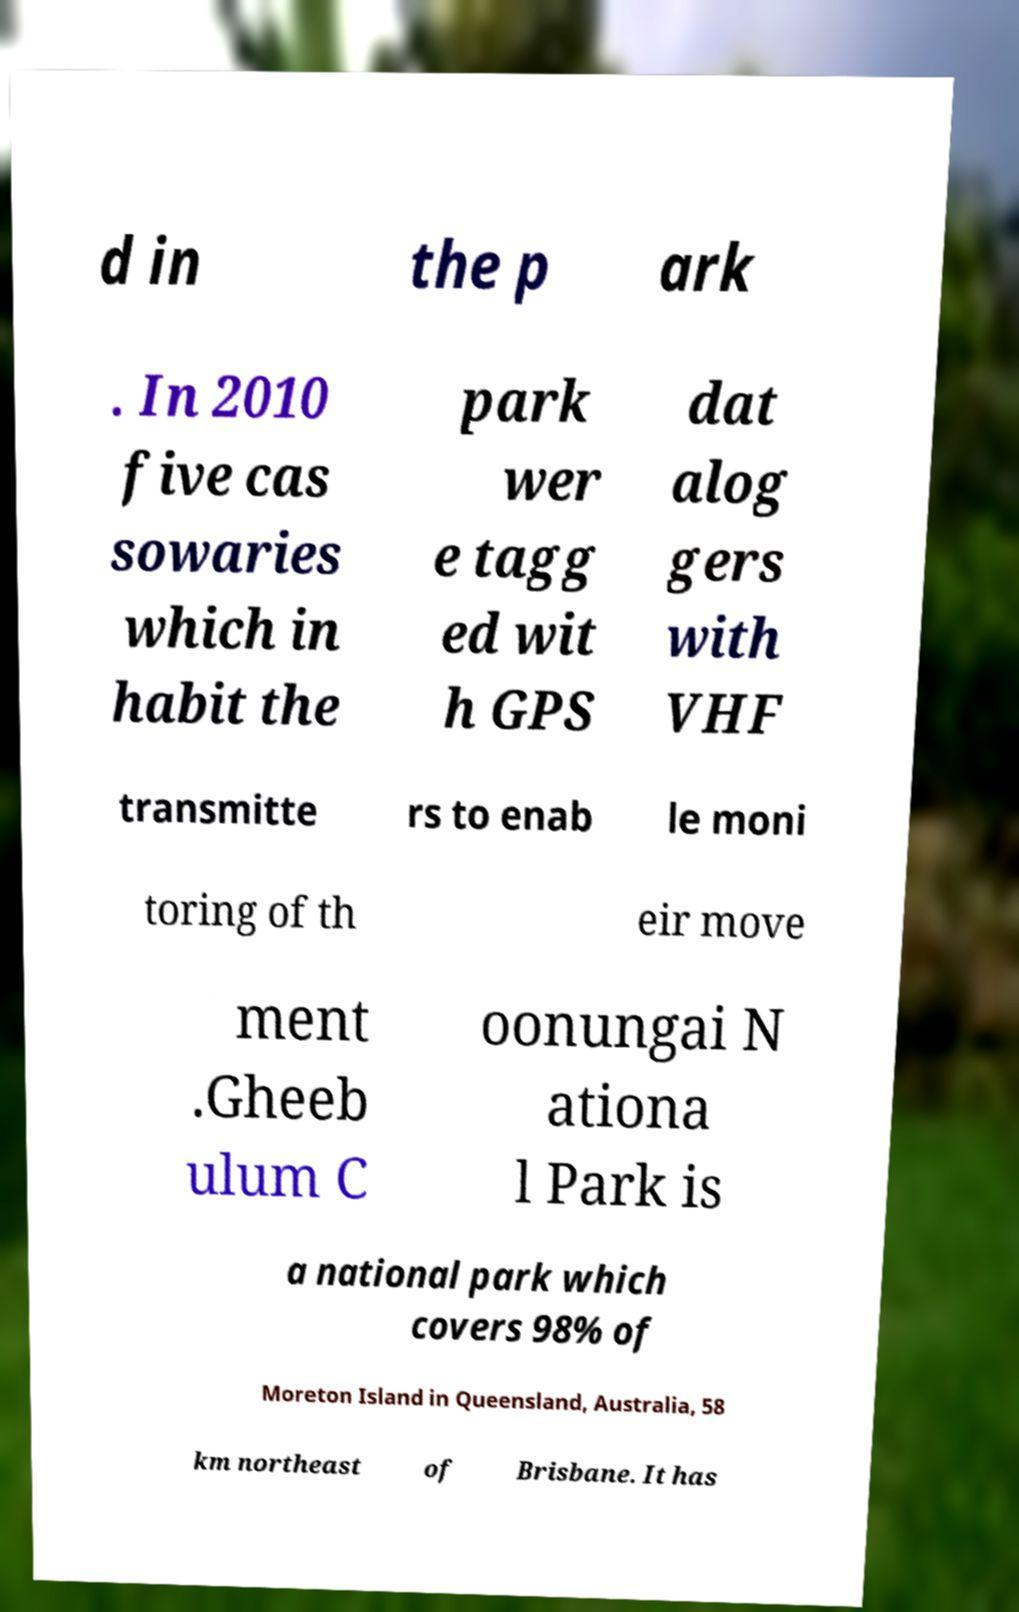What messages or text are displayed in this image? I need them in a readable, typed format. d in the p ark . In 2010 five cas sowaries which in habit the park wer e tagg ed wit h GPS dat alog gers with VHF transmitte rs to enab le moni toring of th eir move ment .Gheeb ulum C oonungai N ationa l Park is a national park which covers 98% of Moreton Island in Queensland, Australia, 58 km northeast of Brisbane. It has 